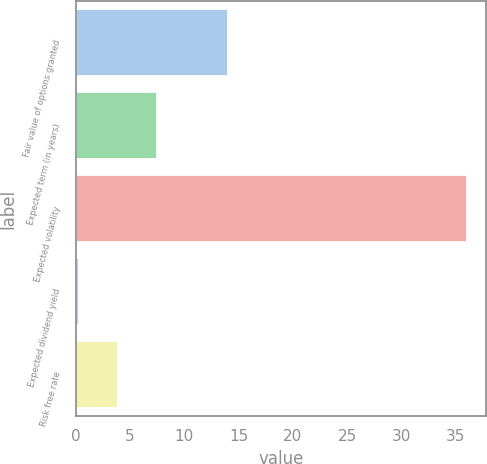Convert chart to OTSL. <chart><loc_0><loc_0><loc_500><loc_500><bar_chart><fcel>Fair value of options granted<fcel>Expected term (in years)<fcel>Expected volatility<fcel>Expected dividend yield<fcel>Risk free rate<nl><fcel>14<fcel>7.44<fcel>36<fcel>0.3<fcel>3.87<nl></chart> 